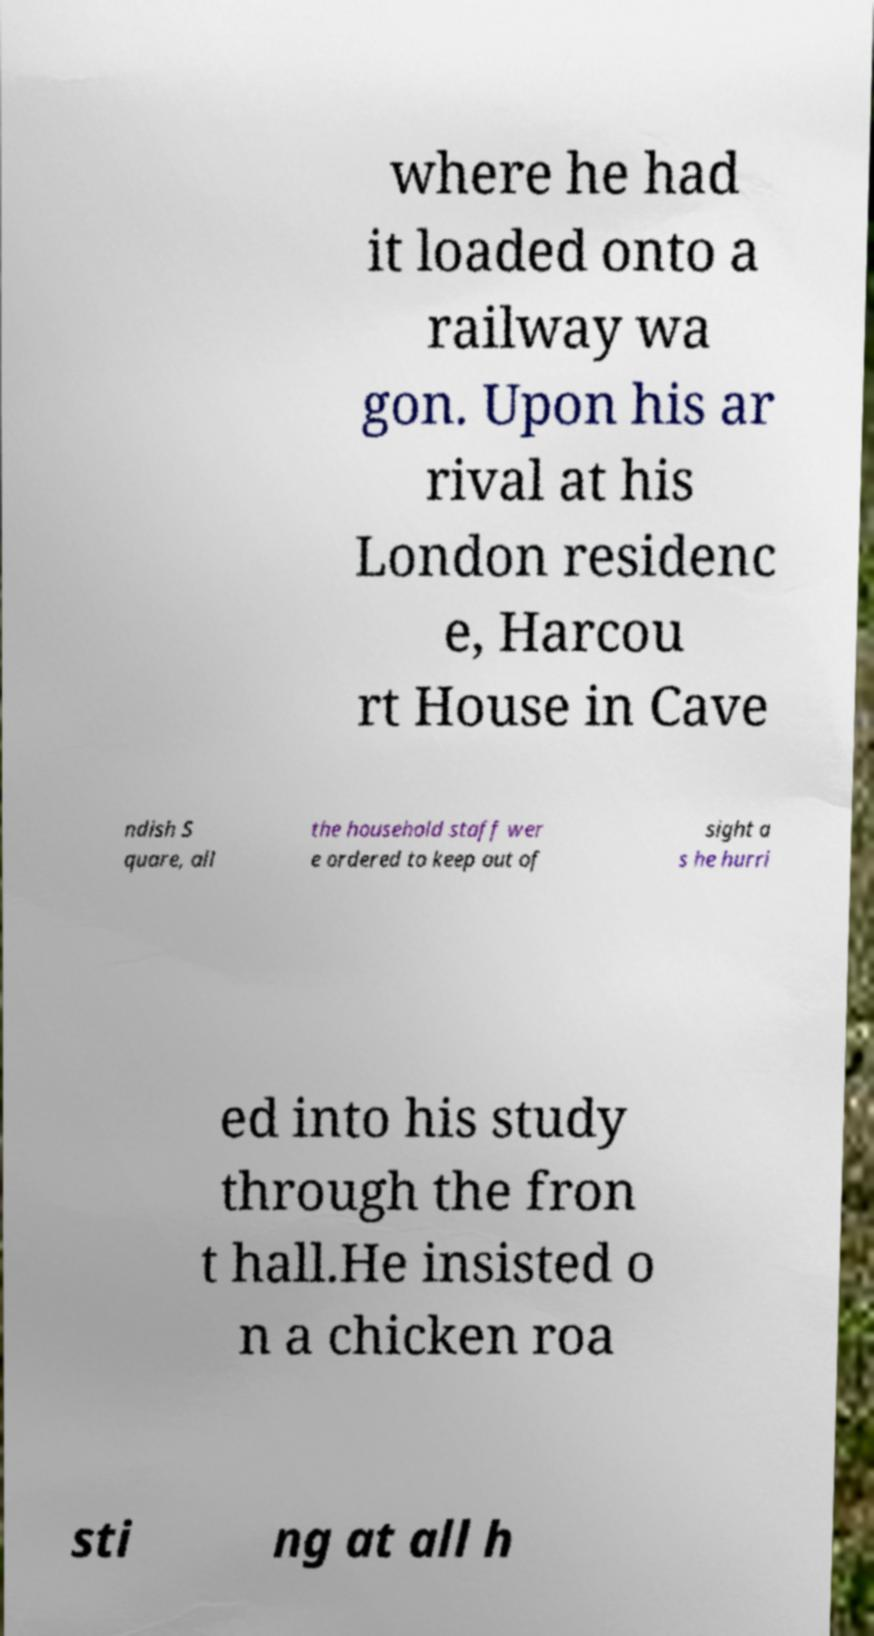What messages or text are displayed in this image? I need them in a readable, typed format. where he had it loaded onto a railway wa gon. Upon his ar rival at his London residenc e, Harcou rt House in Cave ndish S quare, all the household staff wer e ordered to keep out of sight a s he hurri ed into his study through the fron t hall.He insisted o n a chicken roa sti ng at all h 